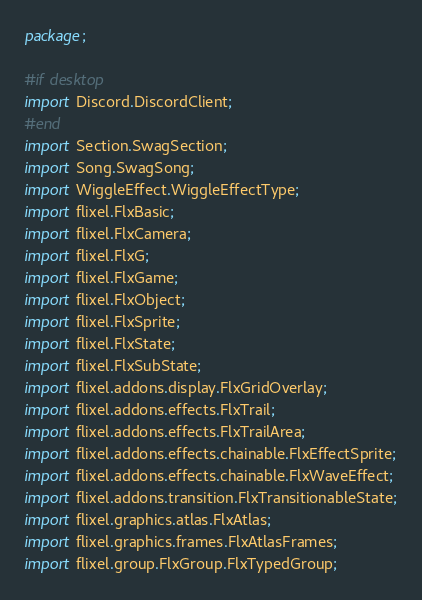Convert code to text. <code><loc_0><loc_0><loc_500><loc_500><_Haxe_>package;

#if desktop
import Discord.DiscordClient;
#end
import Section.SwagSection;
import Song.SwagSong;
import WiggleEffect.WiggleEffectType;
import flixel.FlxBasic;
import flixel.FlxCamera;
import flixel.FlxG;
import flixel.FlxGame;
import flixel.FlxObject;
import flixel.FlxSprite;
import flixel.FlxState;
import flixel.FlxSubState;
import flixel.addons.display.FlxGridOverlay;
import flixel.addons.effects.FlxTrail;
import flixel.addons.effects.FlxTrailArea;
import flixel.addons.effects.chainable.FlxEffectSprite;
import flixel.addons.effects.chainable.FlxWaveEffect;
import flixel.addons.transition.FlxTransitionableState;
import flixel.graphics.atlas.FlxAtlas;
import flixel.graphics.frames.FlxAtlasFrames;
import flixel.group.FlxGroup.FlxTypedGroup;</code> 